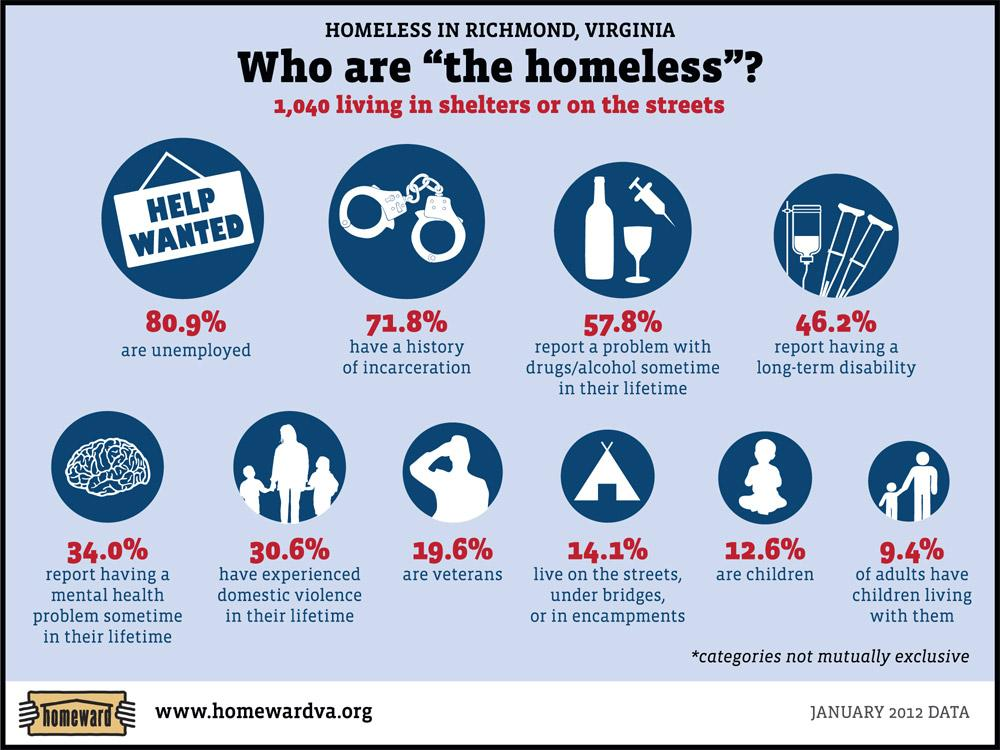Identify some key points in this picture. According to a recent study, only 46.2% of homeless individuals have a long-term disability, suggesting that a significant portion of the homeless population is not disabled. 